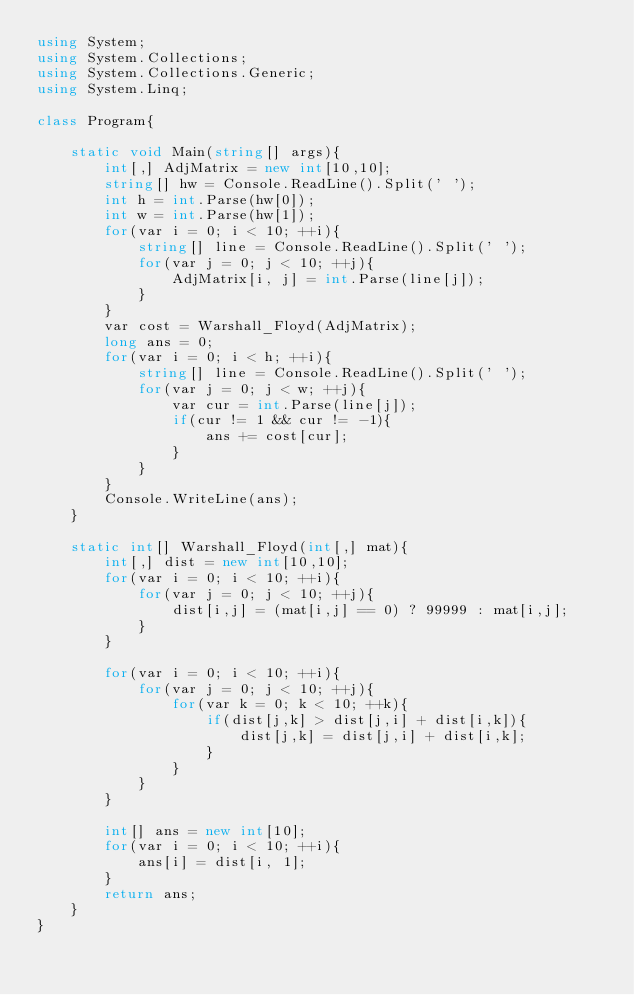<code> <loc_0><loc_0><loc_500><loc_500><_C#_>using System;
using System.Collections;
using System.Collections.Generic;
using System.Linq;

class Program{

    static void Main(string[] args){
        int[,] AdjMatrix = new int[10,10];
        string[] hw = Console.ReadLine().Split(' ');
        int h = int.Parse(hw[0]);
        int w = int.Parse(hw[1]);
        for(var i = 0; i < 10; ++i){
            string[] line = Console.ReadLine().Split(' ');
            for(var j = 0; j < 10; ++j){
                AdjMatrix[i, j] = int.Parse(line[j]);
            }
        }
        var cost = Warshall_Floyd(AdjMatrix);
        long ans = 0;
        for(var i = 0; i < h; ++i){
            string[] line = Console.ReadLine().Split(' ');
            for(var j = 0; j < w; ++j){
                var cur = int.Parse(line[j]);
                if(cur != 1 && cur != -1){
                    ans += cost[cur];
                }
            }
        }
        Console.WriteLine(ans);
    }

    static int[] Warshall_Floyd(int[,] mat){
        int[,] dist = new int[10,10];
        for(var i = 0; i < 10; ++i){
            for(var j = 0; j < 10; ++j){
                dist[i,j] = (mat[i,j] == 0) ? 99999 : mat[i,j];
            }
        }

        for(var i = 0; i < 10; ++i){
            for(var j = 0; j < 10; ++j){
                for(var k = 0; k < 10; ++k){
                    if(dist[j,k] > dist[j,i] + dist[i,k]){
                        dist[j,k] = dist[j,i] + dist[i,k];
                    }
                }
            }
        }

        int[] ans = new int[10];
        for(var i = 0; i < 10; ++i){
            ans[i] = dist[i, 1];
        }
        return ans;
    }
}
</code> 